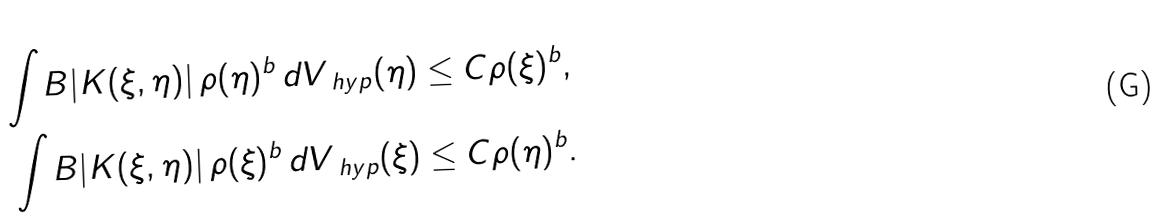Convert formula to latex. <formula><loc_0><loc_0><loc_500><loc_500>\int _ { \ } B | K ( \xi , \eta ) | \, \rho ( \eta ) ^ { b } \, d V _ { \ h y p } ( \eta ) & \leq C \rho ( \xi ) ^ { b } , \\ \int _ { \ } B | K ( \xi , \eta ) | \, \rho ( \xi ) ^ { b } \, d V _ { \ h y p } ( \xi ) & \leq C \rho ( \eta ) ^ { b } .</formula> 